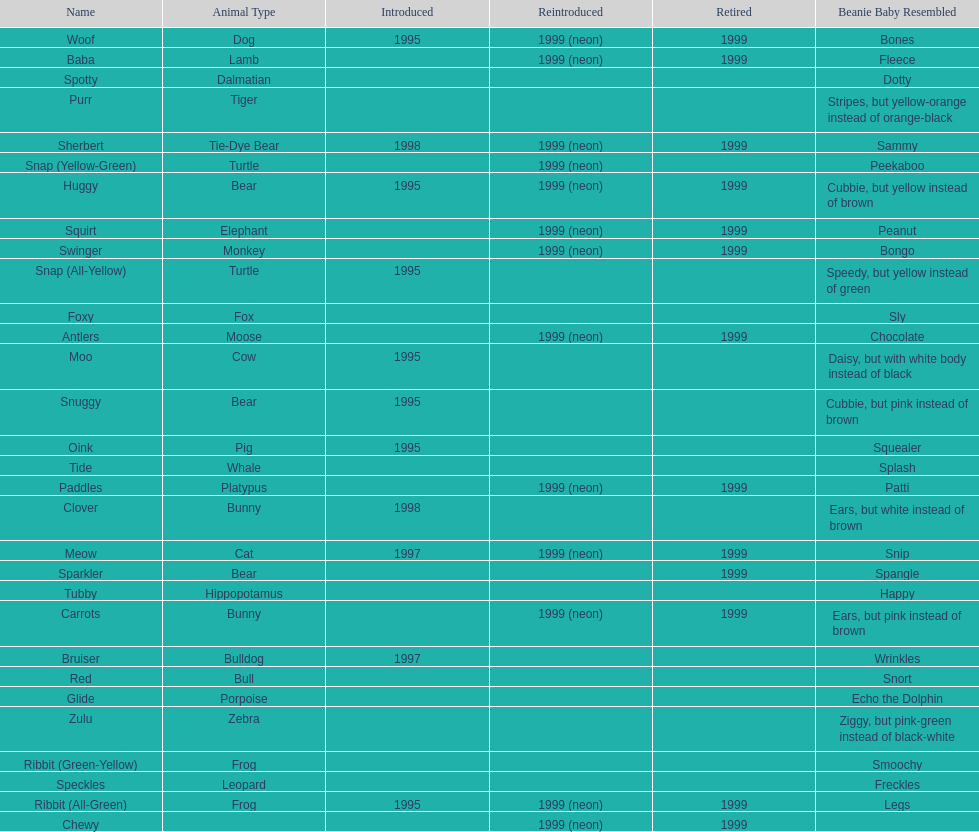What is the number of frog pillow pals? 2. Would you mind parsing the complete table? {'header': ['Name', 'Animal Type', 'Introduced', 'Reintroduced', 'Retired', 'Beanie Baby Resembled'], 'rows': [['Woof', 'Dog', '1995', '1999 (neon)', '1999', 'Bones'], ['Baba', 'Lamb', '', '1999 (neon)', '1999', 'Fleece'], ['Spotty', 'Dalmatian', '', '', '', 'Dotty'], ['Purr', 'Tiger', '', '', '', 'Stripes, but yellow-orange instead of orange-black'], ['Sherbert', 'Tie-Dye Bear', '1998', '1999 (neon)', '1999', 'Sammy'], ['Snap (Yellow-Green)', 'Turtle', '', '1999 (neon)', '', 'Peekaboo'], ['Huggy', 'Bear', '1995', '1999 (neon)', '1999', 'Cubbie, but yellow instead of brown'], ['Squirt', 'Elephant', '', '1999 (neon)', '1999', 'Peanut'], ['Swinger', 'Monkey', '', '1999 (neon)', '1999', 'Bongo'], ['Snap (All-Yellow)', 'Turtle', '1995', '', '', 'Speedy, but yellow instead of green'], ['Foxy', 'Fox', '', '', '', 'Sly'], ['Antlers', 'Moose', '', '1999 (neon)', '1999', 'Chocolate'], ['Moo', 'Cow', '1995', '', '', 'Daisy, but with white body instead of black'], ['Snuggy', 'Bear', '1995', '', '', 'Cubbie, but pink instead of brown'], ['Oink', 'Pig', '1995', '', '', 'Squealer'], ['Tide', 'Whale', '', '', '', 'Splash'], ['Paddles', 'Platypus', '', '1999 (neon)', '1999', 'Patti'], ['Clover', 'Bunny', '1998', '', '', 'Ears, but white instead of brown'], ['Meow', 'Cat', '1997', '1999 (neon)', '1999', 'Snip'], ['Sparkler', 'Bear', '', '', '1999', 'Spangle'], ['Tubby', 'Hippopotamus', '', '', '', 'Happy'], ['Carrots', 'Bunny', '', '1999 (neon)', '1999', 'Ears, but pink instead of brown'], ['Bruiser', 'Bulldog', '1997', '', '', 'Wrinkles'], ['Red', 'Bull', '', '', '', 'Snort'], ['Glide', 'Porpoise', '', '', '', 'Echo the Dolphin'], ['Zulu', 'Zebra', '', '', '', 'Ziggy, but pink-green instead of black-white'], ['Ribbit (Green-Yellow)', 'Frog', '', '', '', 'Smoochy'], ['Speckles', 'Leopard', '', '', '', 'Freckles'], ['Ribbit (All-Green)', 'Frog', '1995', '1999 (neon)', '1999', 'Legs'], ['Chewy', '', '', '1999 (neon)', '1999', '']]} 